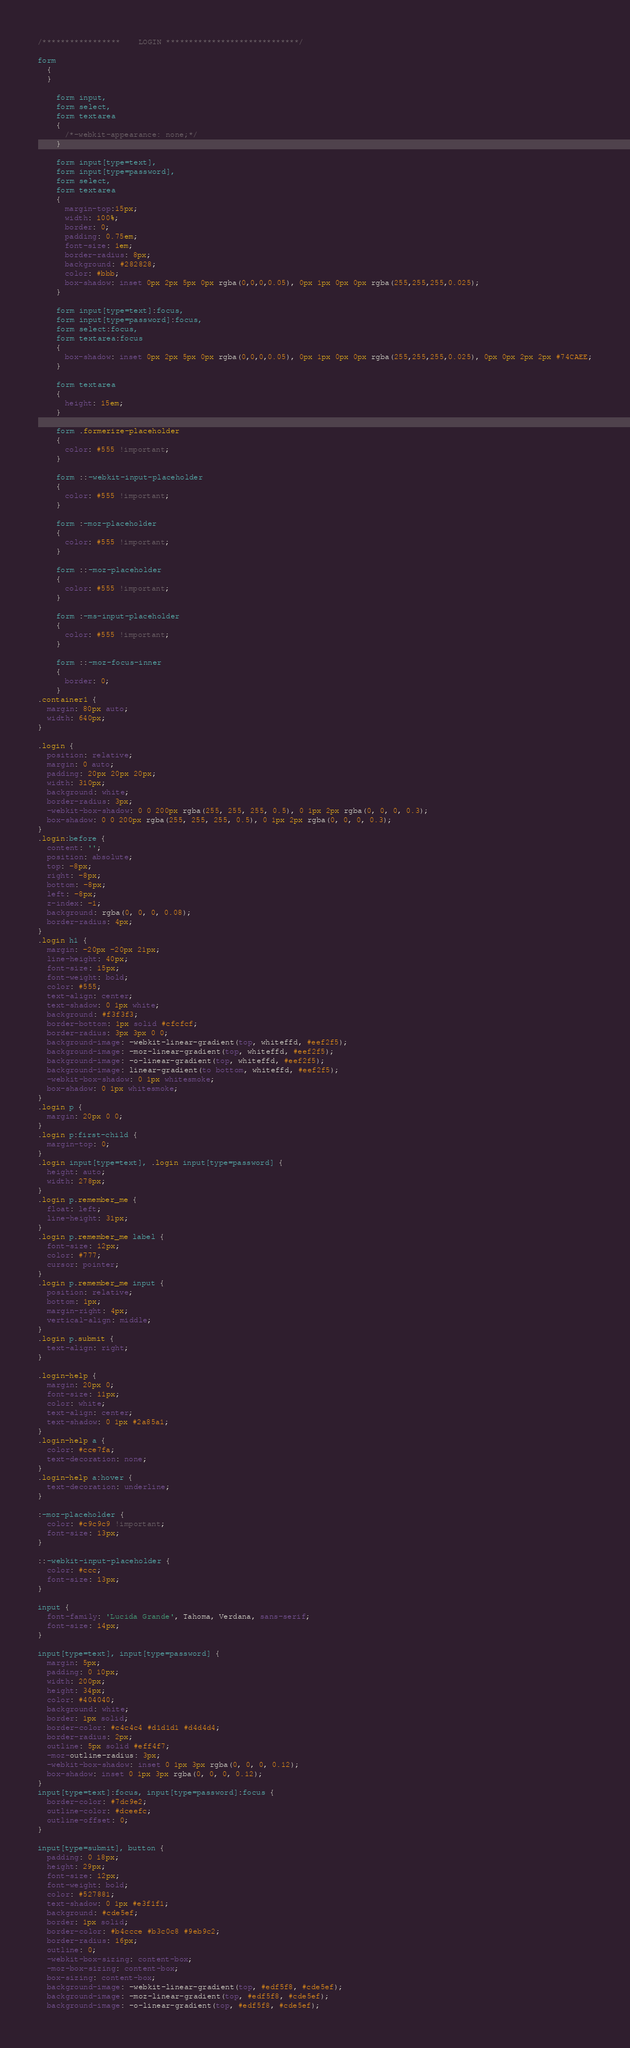Convert code to text. <code><loc_0><loc_0><loc_500><loc_500><_CSS_>/*****************    LOGIN *****************************/

form
  {
  }
  
    form input,
    form select,
    form textarea
    {
      /*-webkit-appearance: none;*/
    }

    form input[type=text],
    form input[type=password],
    form select,
    form textarea
    {
      margin-top:15px;
      width: 100%;
      border: 0;
      padding: 0.75em;
      font-size: 1em;
      border-radius: 8px;
      background: #282828;
      color: #bbb;
      box-shadow: inset 0px 2px 5px 0px rgba(0,0,0,0.05), 0px 1px 0px 0px rgba(255,255,255,0.025);
    }

    form input[type=text]:focus,
    form input[type=password]:focus,
    form select:focus,
    form textarea:focus
    {
      box-shadow: inset 0px 2px 5px 0px rgba(0,0,0,0.05), 0px 1px 0px 0px rgba(255,255,255,0.025), 0px 0px 2px 2px #74CAEE;
    }
    
    form textarea
    {
      height: 15em;
    }
    
    form .formerize-placeholder
    {
      color: #555 !important;
    }

    form ::-webkit-input-placeholder
    {
      color: #555 !important;
    }

    form :-moz-placeholder
    {
      color: #555 !important;
    }

    form ::-moz-placeholder
    {
      color: #555 !important;
    }

    form :-ms-input-placeholder
    {
      color: #555 !important;
    }

    form ::-moz-focus-inner
    {
      border: 0;
    }
.container1 {
  margin: 80px auto;
  width: 640px;
}

.login {
  position: relative;
  margin: 0 auto;
  padding: 20px 20px 20px;
  width: 310px;
  background: white;
  border-radius: 3px;
  -webkit-box-shadow: 0 0 200px rgba(255, 255, 255, 0.5), 0 1px 2px rgba(0, 0, 0, 0.3);
  box-shadow: 0 0 200px rgba(255, 255, 255, 0.5), 0 1px 2px rgba(0, 0, 0, 0.3);
}
.login:before {
  content: '';
  position: absolute;
  top: -8px;
  right: -8px;
  bottom: -8px;
  left: -8px;
  z-index: -1;
  background: rgba(0, 0, 0, 0.08);
  border-radius: 4px;
}
.login h1 {
  margin: -20px -20px 21px;
  line-height: 40px;
  font-size: 15px;
  font-weight: bold;
  color: #555;
  text-align: center;
  text-shadow: 0 1px white;
  background: #f3f3f3;
  border-bottom: 1px solid #cfcfcf;
  border-radius: 3px 3px 0 0;
  background-image: -webkit-linear-gradient(top, whiteffd, #eef2f5);
  background-image: -moz-linear-gradient(top, whiteffd, #eef2f5);
  background-image: -o-linear-gradient(top, whiteffd, #eef2f5);
  background-image: linear-gradient(to bottom, whiteffd, #eef2f5);
  -webkit-box-shadow: 0 1px whitesmoke;
  box-shadow: 0 1px whitesmoke;
}
.login p {
  margin: 20px 0 0;
}
.login p:first-child {
  margin-top: 0;
}
.login input[type=text], .login input[type=password] {
  height: auto;
  width: 278px;
}
.login p.remember_me {
  float: left;
  line-height: 31px;
}
.login p.remember_me label {
  font-size: 12px;
  color: #777;
  cursor: pointer;
}
.login p.remember_me input {
  position: relative;
  bottom: 1px;
  margin-right: 4px;
  vertical-align: middle;
}
.login p.submit {
  text-align: right;
}

.login-help {
  margin: 20px 0;
  font-size: 11px;
  color: white;
  text-align: center;
  text-shadow: 0 1px #2a85a1;
}
.login-help a {
  color: #cce7fa;
  text-decoration: none;
}
.login-help a:hover {
  text-decoration: underline;
}

:-moz-placeholder {
  color: #c9c9c9 !important;
  font-size: 13px;
}

::-webkit-input-placeholder {
  color: #ccc;
  font-size: 13px;
}

input {
  font-family: 'Lucida Grande', Tahoma, Verdana, sans-serif;
  font-size: 14px;
}

input[type=text], input[type=password] {
  margin: 5px;
  padding: 0 10px;
  width: 200px;
  height: 34px;
  color: #404040;
  background: white;
  border: 1px solid;
  border-color: #c4c4c4 #d1d1d1 #d4d4d4;
  border-radius: 2px;
  outline: 5px solid #eff4f7;
  -moz-outline-radius: 3px;
  -webkit-box-shadow: inset 0 1px 3px rgba(0, 0, 0, 0.12);
  box-shadow: inset 0 1px 3px rgba(0, 0, 0, 0.12);
}
input[type=text]:focus, input[type=password]:focus {
  border-color: #7dc9e2;
  outline-color: #dceefc;
  outline-offset: 0;
}

input[type=submit], button {
  padding: 0 18px;
  height: 29px;
  font-size: 12px;
  font-weight: bold;
  color: #527881;
  text-shadow: 0 1px #e3f1f1;
  background: #cde5ef;
  border: 1px solid;
  border-color: #b4ccce #b3c0c8 #9eb9c2;
  border-radius: 16px;
  outline: 0;
  -webkit-box-sizing: content-box;
  -moz-box-sizing: content-box;
  box-sizing: content-box;
  background-image: -webkit-linear-gradient(top, #edf5f8, #cde5ef);
  background-image: -moz-linear-gradient(top, #edf5f8, #cde5ef);
  background-image: -o-linear-gradient(top, #edf5f8, #cde5ef);</code> 